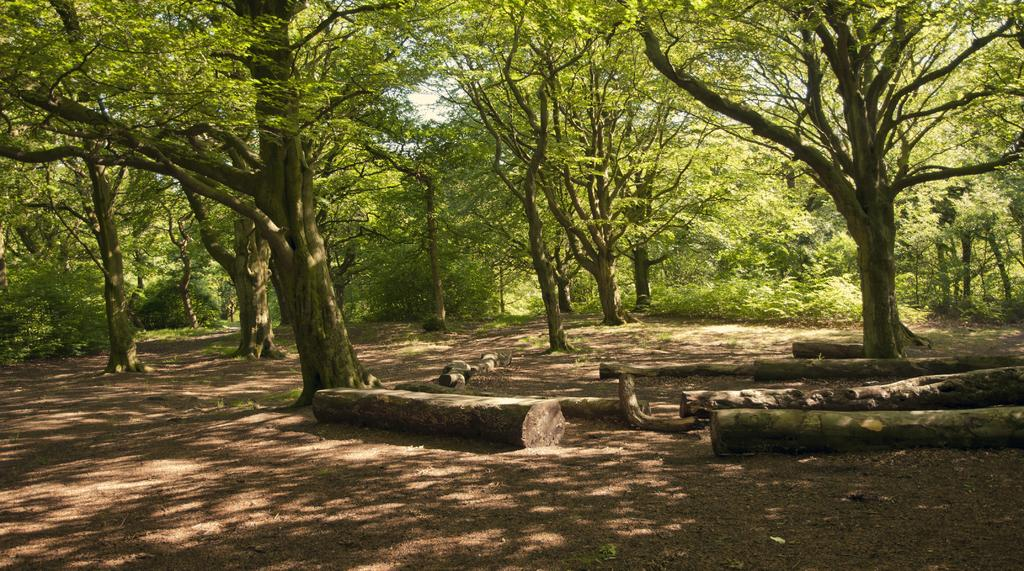What objects are on the ground in the image? There are wooden logs on the ground in the image. What can be seen in the background of the image? Trees and the sky are visible in the background of the image. Where is the baby sitting in the image? There is no baby present in the image. What type of corn can be seen growing near the wooden logs? There is no corn present in the image. 